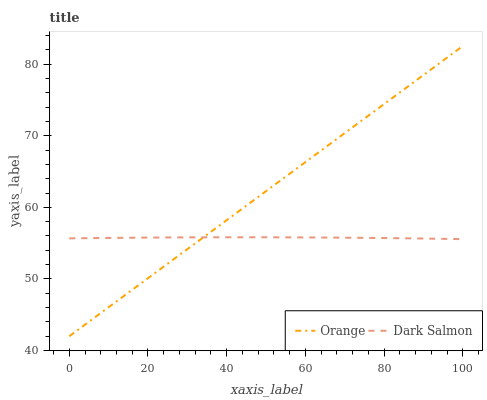Does Dark Salmon have the minimum area under the curve?
Answer yes or no. Yes. Does Orange have the maximum area under the curve?
Answer yes or no. Yes. Does Dark Salmon have the maximum area under the curve?
Answer yes or no. No. Is Orange the smoothest?
Answer yes or no. Yes. Is Dark Salmon the roughest?
Answer yes or no. Yes. Is Dark Salmon the smoothest?
Answer yes or no. No. Does Orange have the lowest value?
Answer yes or no. Yes. Does Dark Salmon have the lowest value?
Answer yes or no. No. Does Orange have the highest value?
Answer yes or no. Yes. Does Dark Salmon have the highest value?
Answer yes or no. No. Does Orange intersect Dark Salmon?
Answer yes or no. Yes. Is Orange less than Dark Salmon?
Answer yes or no. No. Is Orange greater than Dark Salmon?
Answer yes or no. No. 